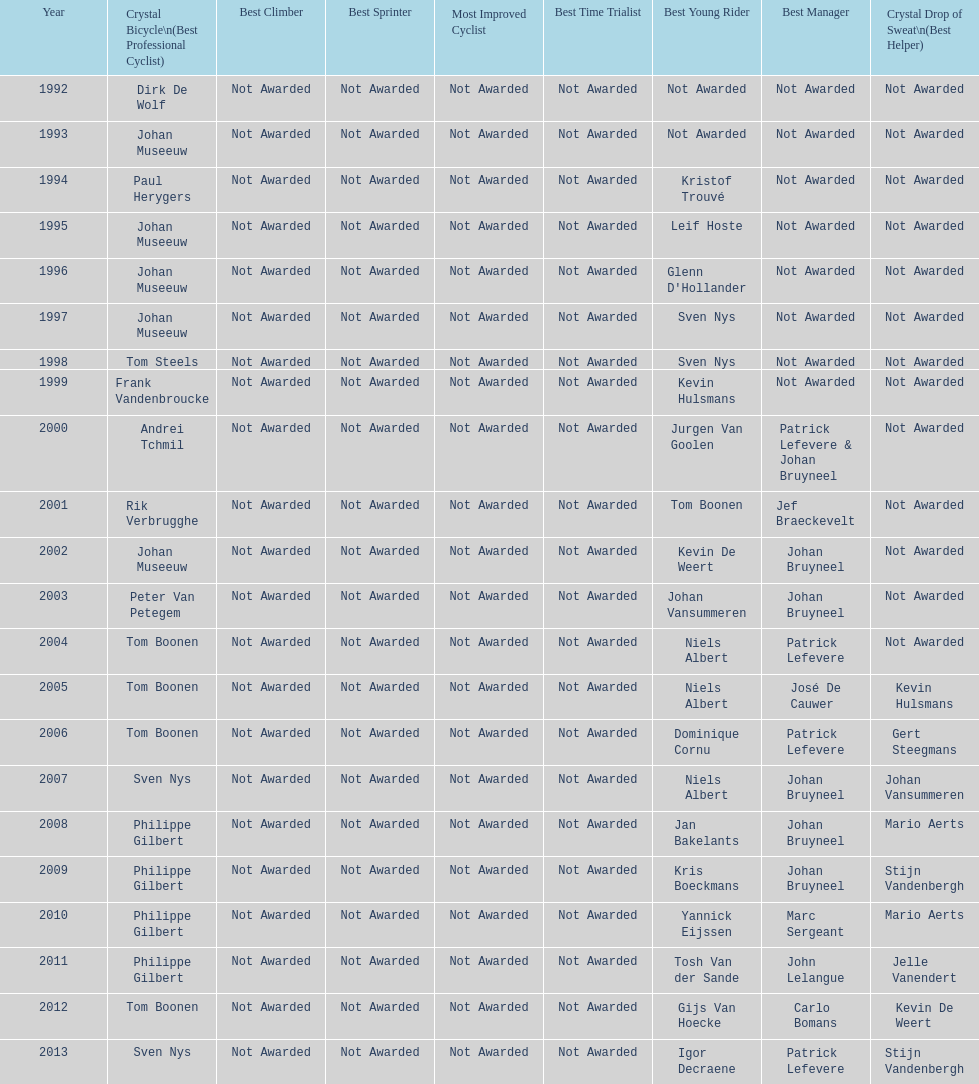What is the total number of times johan bryneel's name appears on all of these lists? 6. 